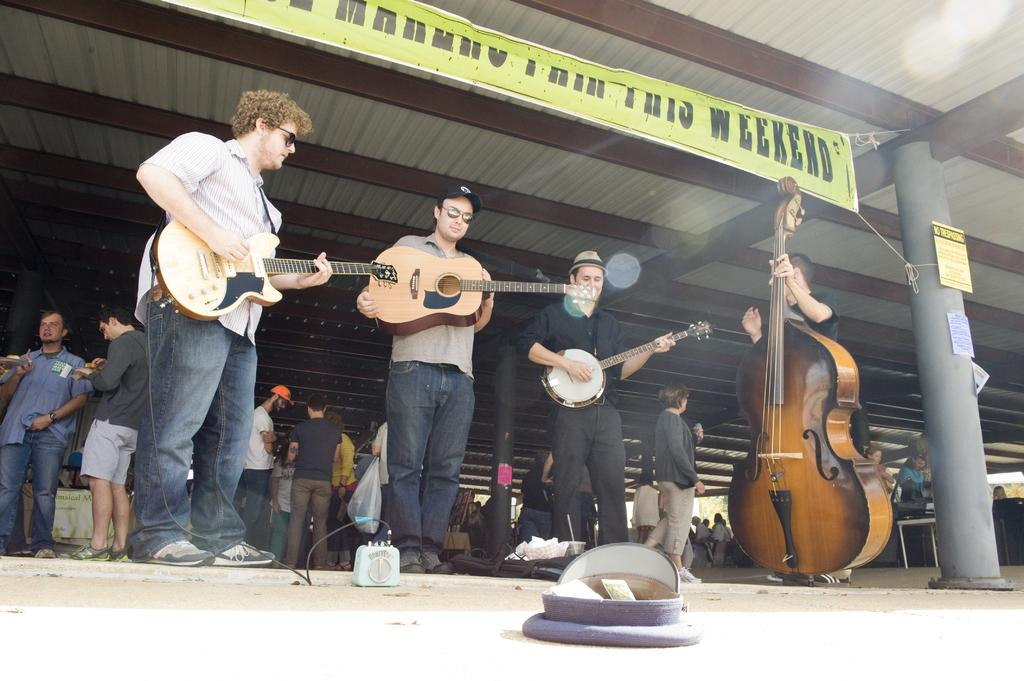How many men are in the image? There are four men in the image. What are the men doing in the image? The men are standing and holding musical instruments. What can be seen in the background of the image? There is a banner in the image, and there are people on a path in the background. What type of ink is used to write the name on the banner in the image? There is no name present on the banner in the image, so it is not possible to determine the type of ink used. 